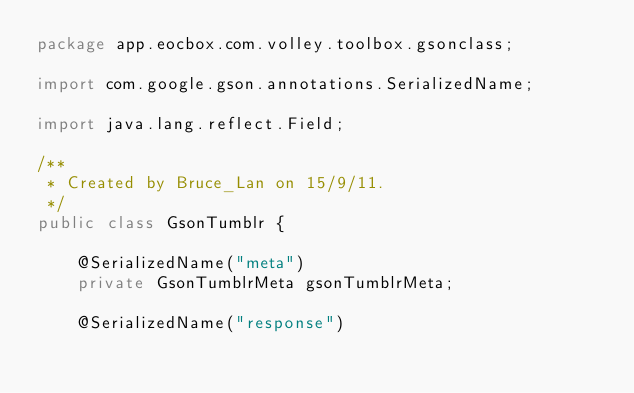<code> <loc_0><loc_0><loc_500><loc_500><_Java_>package app.eocbox.com.volley.toolbox.gsonclass;

import com.google.gson.annotations.SerializedName;

import java.lang.reflect.Field;

/**
 * Created by Bruce_Lan on 15/9/11.
 */
public class GsonTumblr {

    @SerializedName("meta")
    private GsonTumblrMeta gsonTumblrMeta;

    @SerializedName("response")</code> 